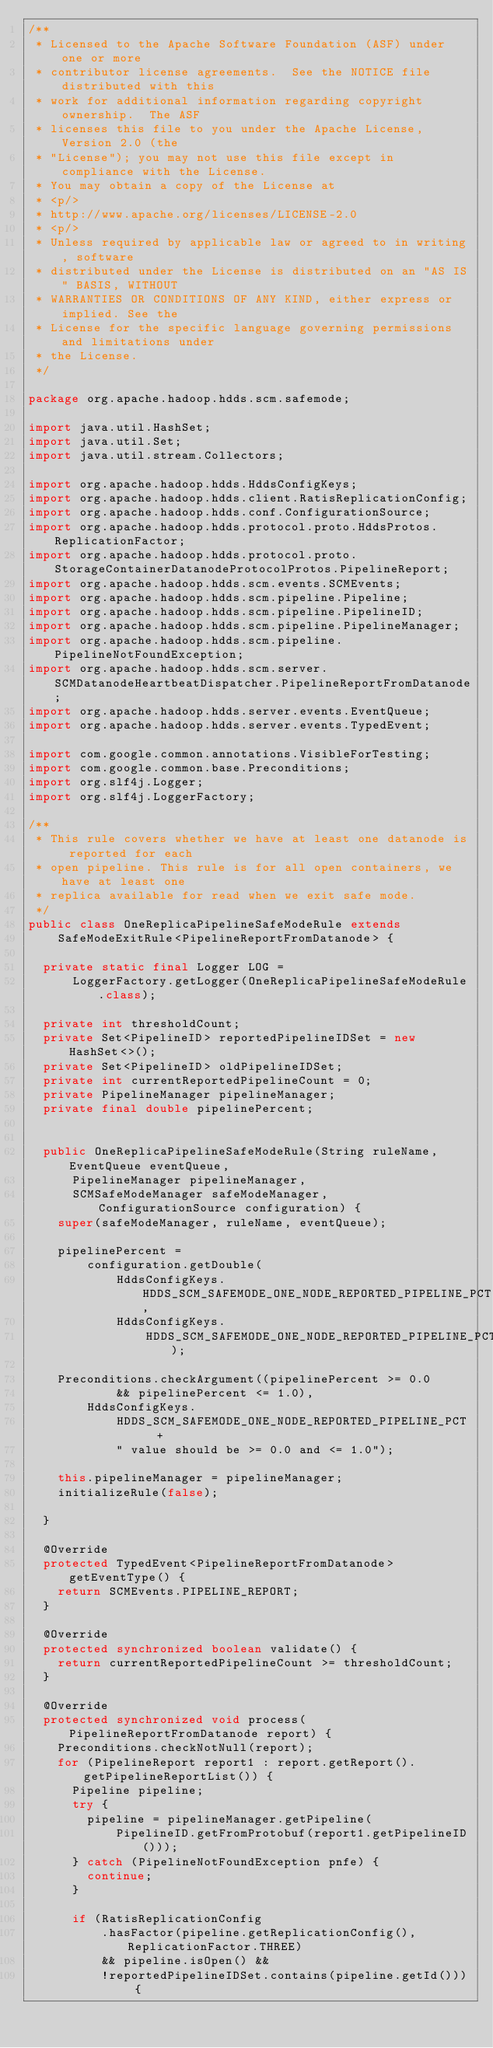Convert code to text. <code><loc_0><loc_0><loc_500><loc_500><_Java_>/**
 * Licensed to the Apache Software Foundation (ASF) under one or more
 * contributor license agreements.  See the NOTICE file distributed with this
 * work for additional information regarding copyright ownership.  The ASF
 * licenses this file to you under the Apache License, Version 2.0 (the
 * "License"); you may not use this file except in compliance with the License.
 * You may obtain a copy of the License at
 * <p/>
 * http://www.apache.org/licenses/LICENSE-2.0
 * <p/>
 * Unless required by applicable law or agreed to in writing, software
 * distributed under the License is distributed on an "AS IS" BASIS, WITHOUT
 * WARRANTIES OR CONDITIONS OF ANY KIND, either express or implied. See the
 * License for the specific language governing permissions and limitations under
 * the License.
 */

package org.apache.hadoop.hdds.scm.safemode;

import java.util.HashSet;
import java.util.Set;
import java.util.stream.Collectors;

import org.apache.hadoop.hdds.HddsConfigKeys;
import org.apache.hadoop.hdds.client.RatisReplicationConfig;
import org.apache.hadoop.hdds.conf.ConfigurationSource;
import org.apache.hadoop.hdds.protocol.proto.HddsProtos.ReplicationFactor;
import org.apache.hadoop.hdds.protocol.proto.StorageContainerDatanodeProtocolProtos.PipelineReport;
import org.apache.hadoop.hdds.scm.events.SCMEvents;
import org.apache.hadoop.hdds.scm.pipeline.Pipeline;
import org.apache.hadoop.hdds.scm.pipeline.PipelineID;
import org.apache.hadoop.hdds.scm.pipeline.PipelineManager;
import org.apache.hadoop.hdds.scm.pipeline.PipelineNotFoundException;
import org.apache.hadoop.hdds.scm.server.SCMDatanodeHeartbeatDispatcher.PipelineReportFromDatanode;
import org.apache.hadoop.hdds.server.events.EventQueue;
import org.apache.hadoop.hdds.server.events.TypedEvent;

import com.google.common.annotations.VisibleForTesting;
import com.google.common.base.Preconditions;
import org.slf4j.Logger;
import org.slf4j.LoggerFactory;

/**
 * This rule covers whether we have at least one datanode is reported for each
 * open pipeline. This rule is for all open containers, we have at least one
 * replica available for read when we exit safe mode.
 */
public class OneReplicaPipelineSafeModeRule extends
    SafeModeExitRule<PipelineReportFromDatanode> {

  private static final Logger LOG =
      LoggerFactory.getLogger(OneReplicaPipelineSafeModeRule.class);

  private int thresholdCount;
  private Set<PipelineID> reportedPipelineIDSet = new HashSet<>();
  private Set<PipelineID> oldPipelineIDSet;
  private int currentReportedPipelineCount = 0;
  private PipelineManager pipelineManager;
  private final double pipelinePercent;


  public OneReplicaPipelineSafeModeRule(String ruleName, EventQueue eventQueue,
      PipelineManager pipelineManager,
      SCMSafeModeManager safeModeManager, ConfigurationSource configuration) {
    super(safeModeManager, ruleName, eventQueue);

    pipelinePercent =
        configuration.getDouble(
            HddsConfigKeys.HDDS_SCM_SAFEMODE_ONE_NODE_REPORTED_PIPELINE_PCT,
            HddsConfigKeys.
                HDDS_SCM_SAFEMODE_ONE_NODE_REPORTED_PIPELINE_PCT_DEFAULT);

    Preconditions.checkArgument((pipelinePercent >= 0.0
            && pipelinePercent <= 1.0),
        HddsConfigKeys.
            HDDS_SCM_SAFEMODE_ONE_NODE_REPORTED_PIPELINE_PCT  +
            " value should be >= 0.0 and <= 1.0");

    this.pipelineManager = pipelineManager;
    initializeRule(false);

  }

  @Override
  protected TypedEvent<PipelineReportFromDatanode> getEventType() {
    return SCMEvents.PIPELINE_REPORT;
  }

  @Override
  protected synchronized boolean validate() {
    return currentReportedPipelineCount >= thresholdCount;
  }

  @Override
  protected synchronized void process(PipelineReportFromDatanode report) {
    Preconditions.checkNotNull(report);
    for (PipelineReport report1 : report.getReport().getPipelineReportList()) {
      Pipeline pipeline;
      try {
        pipeline = pipelineManager.getPipeline(
            PipelineID.getFromProtobuf(report1.getPipelineID()));
      } catch (PipelineNotFoundException pnfe) {
        continue;
      }

      if (RatisReplicationConfig
          .hasFactor(pipeline.getReplicationConfig(), ReplicationFactor.THREE)
          && pipeline.isOpen() &&
          !reportedPipelineIDSet.contains(pipeline.getId())) {</code> 